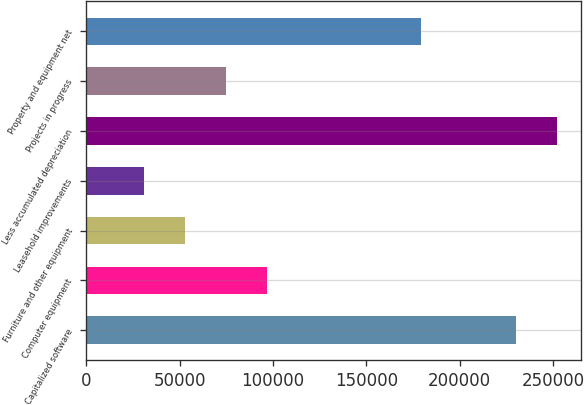Convert chart. <chart><loc_0><loc_0><loc_500><loc_500><bar_chart><fcel>Capitalized software<fcel>Computer equipment<fcel>Furniture and other equipment<fcel>Leasehold improvements<fcel>Less accumulated depreciation<fcel>Projects in progress<fcel>Property and equipment net<nl><fcel>230168<fcel>96550.4<fcel>52680.8<fcel>30746<fcel>252103<fcel>74615.6<fcel>179490<nl></chart> 